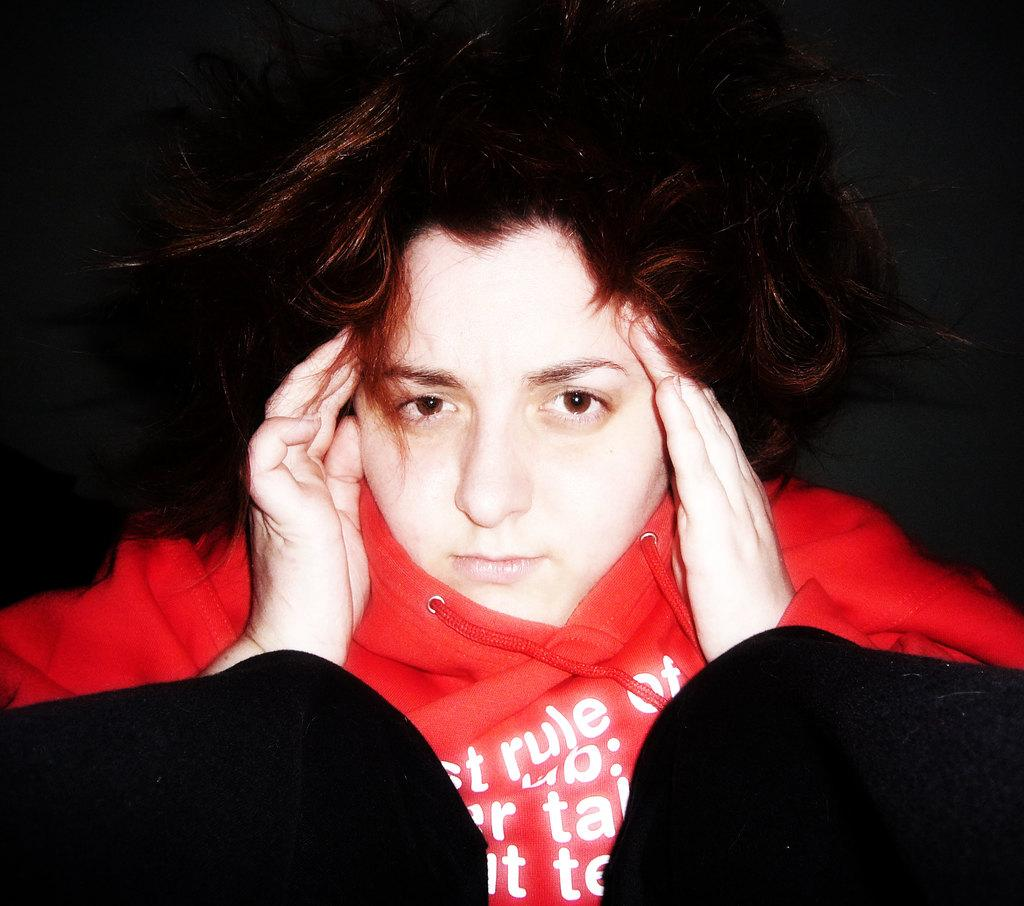Who is the main subject in the image? There is a lady in the image. What is the lady wearing? The lady is wearing a red dress. What can be observed about the background of the image? The background of the image is dark. What type of flag can be seen in the image? There is no flag present in the image. How does the lady fall in the image? The lady is not falling in the image; she is standing still. 